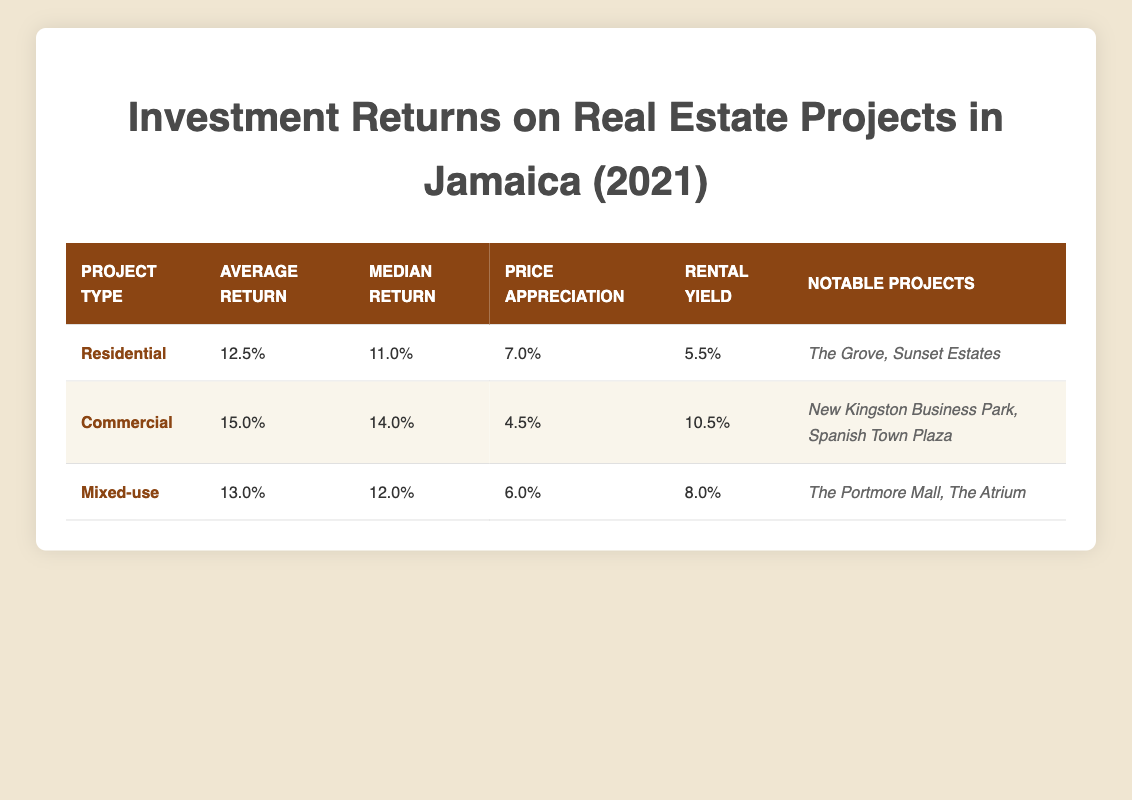What is the average return for Commercial projects? The table indicates that the Average Return for Commercial projects is 15.0.
Answer: 15.0 Which project type has the highest median return? The table shows the Median Returns for Residential, Commercial, and Mixed-use projects as 11.0, 14.0, and 12.0, respectively. The highest is 14.0 for Commercial projects.
Answer: Commercial Is the rental yield for Mixed-use projects higher than that for Residential projects? The table states the Rental Yield for Mixed-use projects is 8.0, while for Residential, it is 5.5. Since 8.0 is greater than 5.5, the answer is yes.
Answer: Yes What is the total average return for all project types combined? To find the total average return, add the Average Returns for all three project types: 12.5 (Residential) + 15.0 (Commercial) + 13.0 (Mixed-use) = 40.5. There are three project types, so the average is 40.5 / 3 = 13.5.
Answer: 13.5 Is it true that all project types have a price appreciation of at least 5%? The price appreciation values from the table are 7.0 (Residential), 4.5 (Commercial), and 6.0 (Mixed-use). Since Commercial has 4.5, which is less than 5, the statement is false.
Answer: No Which project type has the lowest rental yield? By examining the rental yield values, we find that Residential has 5.5, Commercial has 10.5, and Mixed-use has 8.0. Thus, the lowest rental yield is 5.5 for Residential.
Answer: Residential What is the difference in average return between Commercial and Mixed-use projects? To find the difference, subtract the Average Return of Mixed-use (13.0) from that of Commercial (15.0): 15.0 - 13.0 = 2.0.
Answer: 2.0 Which notable project is associated with Residential investment returns? The table lists the notable projects for Residential as "The Grove" and "Sunset Estates". Therefore, either project can be accepted as the answer.
Answer: The Grove (or Sunset Estates) How does the Average Return for Residential projects compare to the Rental Yield of Commercial projects? The Average Return for Residential projects is 12.5, and the Rental Yield for Commercial projects is 10.5. Comparing these, 12.5 is greater than 10.5.
Answer: Average Return is higher 